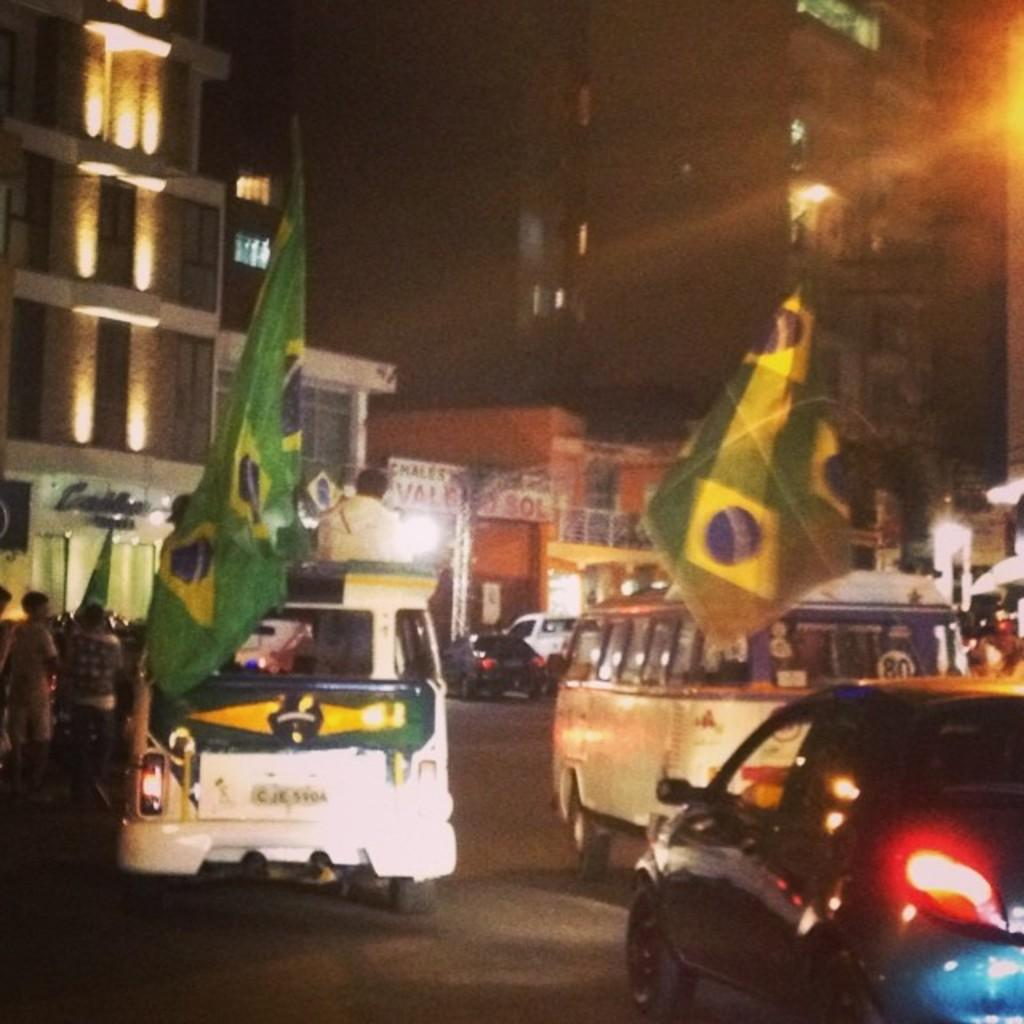<image>
Present a compact description of the photo's key features. A van sports a big green flag and the number 80 on it. 